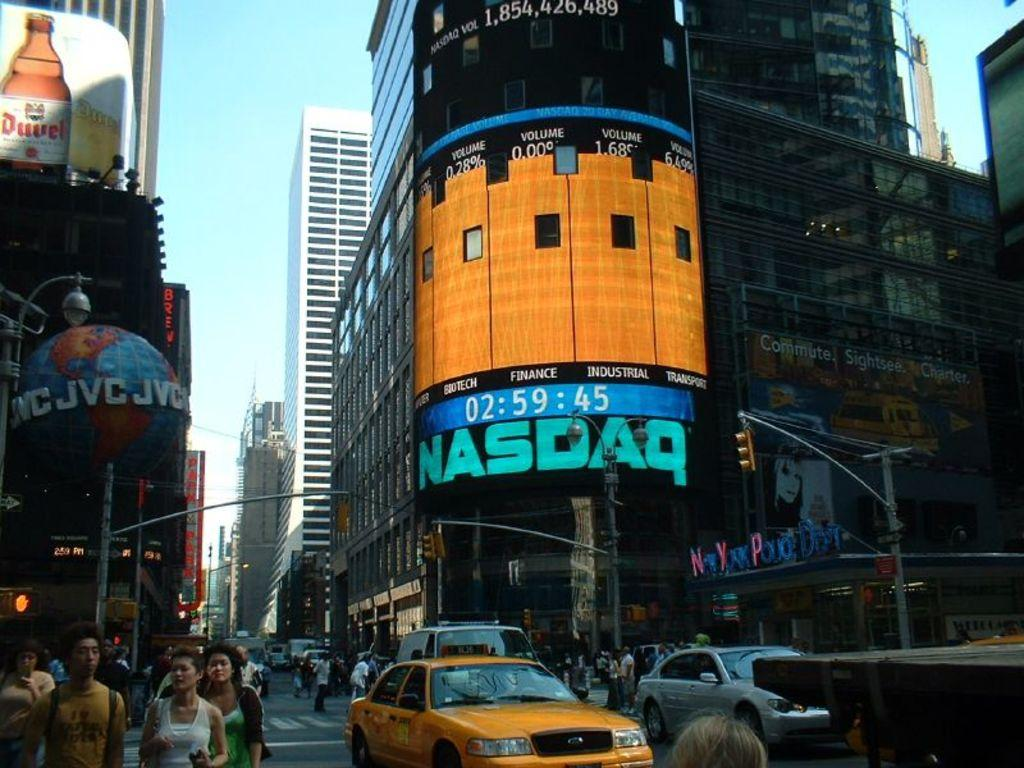<image>
Describe the image concisely. A busy intersection has pedestrians in it and a large sign that says Nasdaq. 